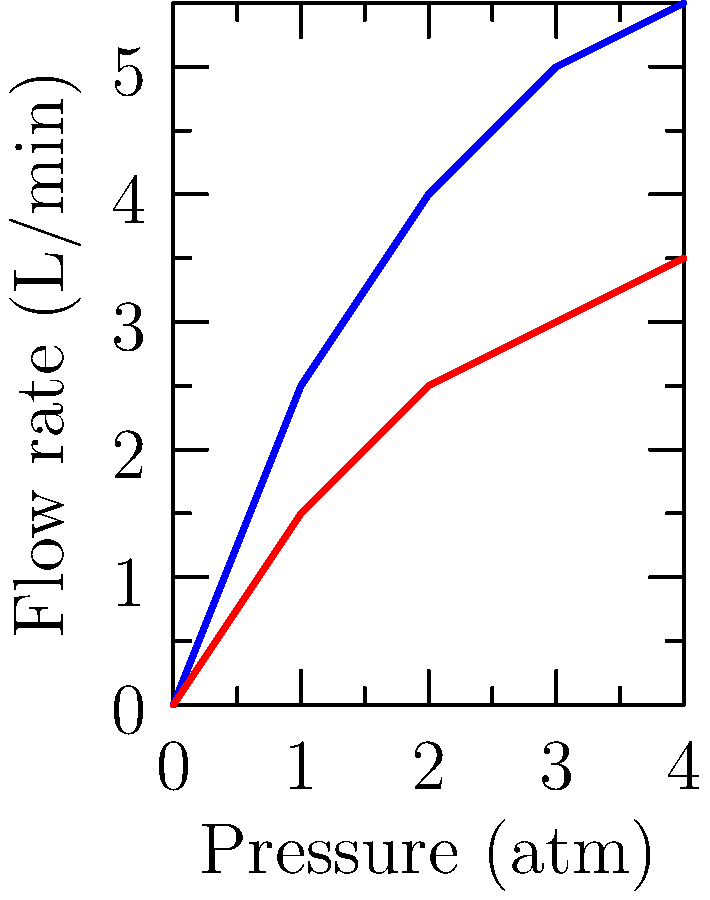Based on the fluid dynamics schematic shown, which represents the flow rate of biofuel through pipes of different diameters under varying pressures, calculate the percentage increase in flow rate when using the larger diameter pipe at a pressure of 3 atm compared to the smaller diameter pipe at the same pressure. To solve this problem, we'll follow these steps:

1. Identify the flow rates for both pipe diameters at 3 atm pressure:
   - Large diameter pipe: 5 L/min
   - Small diameter pipe: 3 L/min

2. Calculate the difference in flow rate:
   $\text{Difference} = 5 \text{ L/min} - 3 \text{ L/min} = 2 \text{ L/min}$

3. Calculate the percentage increase:
   $$\text{Percentage increase} = \frac{\text{Difference}}{\text{Original value}} \times 100\%$$
   $$= \frac{2 \text{ L/min}}{3 \text{ L/min}} \times 100\%$$
   $$= 0.6667 \times 100\%$$
   $$= 66.67\%$$

Therefore, the percentage increase in flow rate when using the larger diameter pipe at 3 atm pressure is approximately 66.67% compared to the smaller diameter pipe at the same pressure.
Answer: 66.67% 